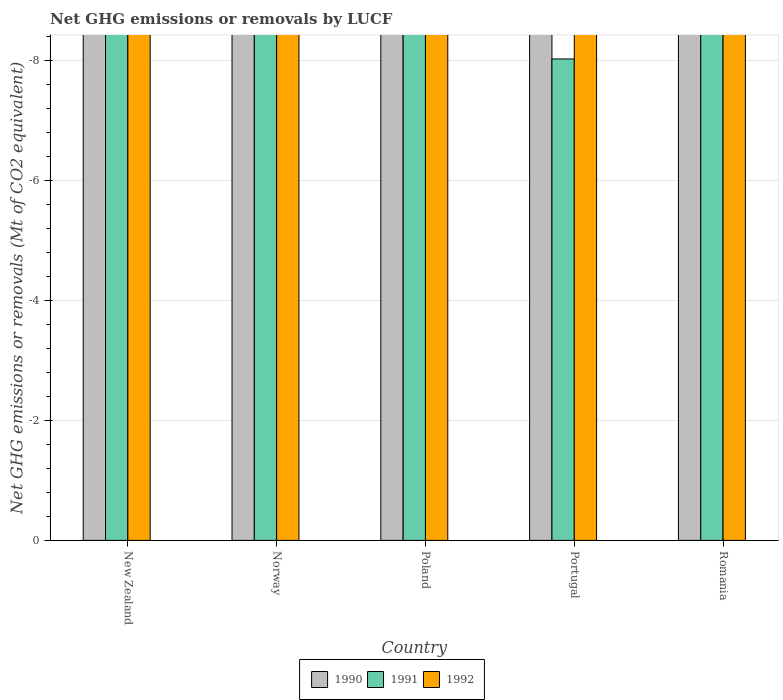Are the number of bars per tick equal to the number of legend labels?
Provide a succinct answer. No. How many bars are there on the 4th tick from the left?
Your answer should be compact. 0. How many bars are there on the 5th tick from the right?
Offer a very short reply. 0. In how many cases, is the number of bars for a given country not equal to the number of legend labels?
Give a very brief answer. 5. What is the net GHG emissions or removals by LUCF in 1992 in Romania?
Give a very brief answer. 0. In how many countries, is the net GHG emissions or removals by LUCF in 1990 greater than the average net GHG emissions or removals by LUCF in 1990 taken over all countries?
Give a very brief answer. 0. Is it the case that in every country, the sum of the net GHG emissions or removals by LUCF in 1991 and net GHG emissions or removals by LUCF in 1992 is greater than the net GHG emissions or removals by LUCF in 1990?
Offer a very short reply. No. How many bars are there?
Give a very brief answer. 0. How many countries are there in the graph?
Keep it short and to the point. 5. Are the values on the major ticks of Y-axis written in scientific E-notation?
Ensure brevity in your answer.  No. Does the graph contain grids?
Make the answer very short. Yes. Where does the legend appear in the graph?
Your answer should be compact. Bottom center. How are the legend labels stacked?
Provide a short and direct response. Horizontal. What is the title of the graph?
Offer a terse response. Net GHG emissions or removals by LUCF. What is the label or title of the X-axis?
Offer a terse response. Country. What is the label or title of the Y-axis?
Provide a succinct answer. Net GHG emissions or removals (Mt of CO2 equivalent). What is the Net GHG emissions or removals (Mt of CO2 equivalent) in 1991 in Norway?
Your response must be concise. 0. What is the Net GHG emissions or removals (Mt of CO2 equivalent) of 1992 in Norway?
Keep it short and to the point. 0. What is the Net GHG emissions or removals (Mt of CO2 equivalent) in 1991 in Poland?
Offer a terse response. 0. What is the Net GHG emissions or removals (Mt of CO2 equivalent) in 1992 in Poland?
Offer a terse response. 0. What is the Net GHG emissions or removals (Mt of CO2 equivalent) of 1990 in Portugal?
Keep it short and to the point. 0. What is the Net GHG emissions or removals (Mt of CO2 equivalent) of 1992 in Portugal?
Your response must be concise. 0. What is the Net GHG emissions or removals (Mt of CO2 equivalent) in 1992 in Romania?
Make the answer very short. 0. What is the total Net GHG emissions or removals (Mt of CO2 equivalent) of 1990 in the graph?
Ensure brevity in your answer.  0. What is the total Net GHG emissions or removals (Mt of CO2 equivalent) in 1991 in the graph?
Your answer should be very brief. 0. What is the total Net GHG emissions or removals (Mt of CO2 equivalent) in 1992 in the graph?
Provide a short and direct response. 0. What is the average Net GHG emissions or removals (Mt of CO2 equivalent) of 1992 per country?
Provide a succinct answer. 0. 